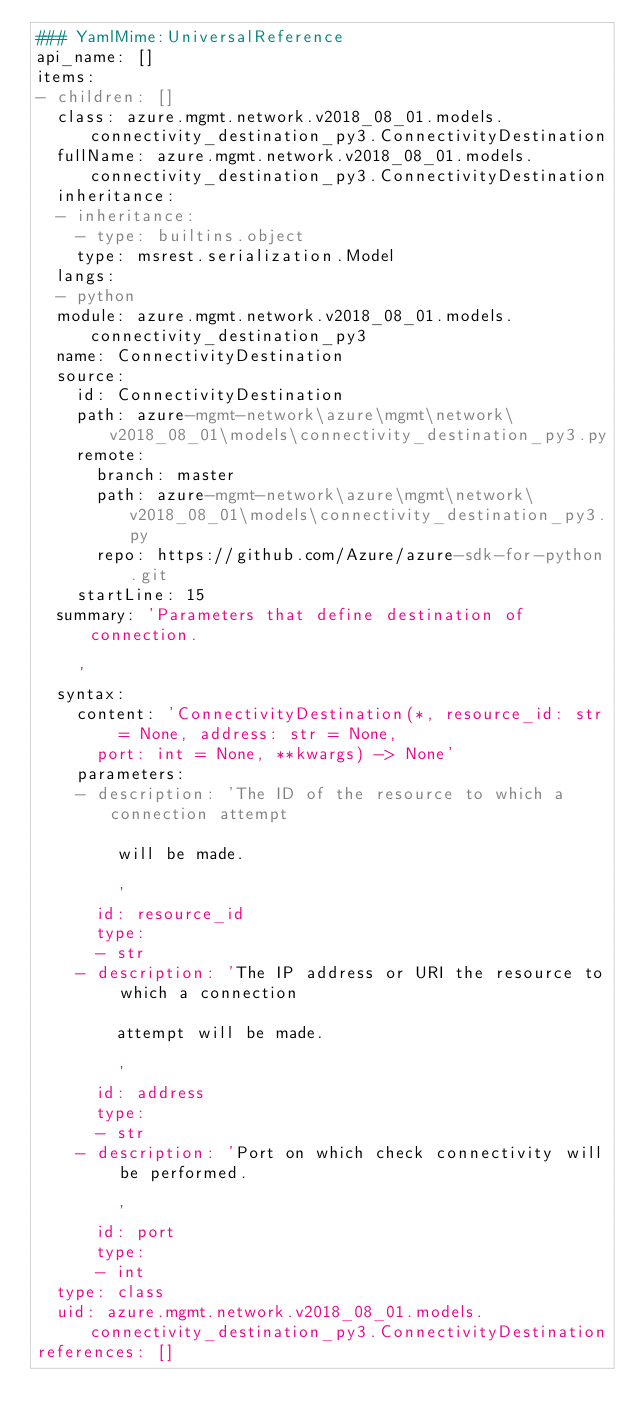<code> <loc_0><loc_0><loc_500><loc_500><_YAML_>### YamlMime:UniversalReference
api_name: []
items:
- children: []
  class: azure.mgmt.network.v2018_08_01.models.connectivity_destination_py3.ConnectivityDestination
  fullName: azure.mgmt.network.v2018_08_01.models.connectivity_destination_py3.ConnectivityDestination
  inheritance:
  - inheritance:
    - type: builtins.object
    type: msrest.serialization.Model
  langs:
  - python
  module: azure.mgmt.network.v2018_08_01.models.connectivity_destination_py3
  name: ConnectivityDestination
  source:
    id: ConnectivityDestination
    path: azure-mgmt-network\azure\mgmt\network\v2018_08_01\models\connectivity_destination_py3.py
    remote:
      branch: master
      path: azure-mgmt-network\azure\mgmt\network\v2018_08_01\models\connectivity_destination_py3.py
      repo: https://github.com/Azure/azure-sdk-for-python.git
    startLine: 15
  summary: 'Parameters that define destination of connection.

    '
  syntax:
    content: 'ConnectivityDestination(*, resource_id: str = None, address: str = None,
      port: int = None, **kwargs) -> None'
    parameters:
    - description: 'The ID of the resource to which a connection attempt

        will be made.

        '
      id: resource_id
      type:
      - str
    - description: 'The IP address or URI the resource to which a connection

        attempt will be made.

        '
      id: address
      type:
      - str
    - description: 'Port on which check connectivity will be performed.

        '
      id: port
      type:
      - int
  type: class
  uid: azure.mgmt.network.v2018_08_01.models.connectivity_destination_py3.ConnectivityDestination
references: []
</code> 